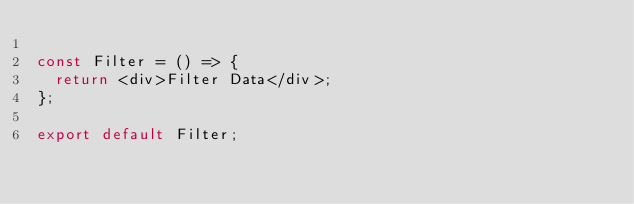Convert code to text. <code><loc_0><loc_0><loc_500><loc_500><_JavaScript_>
const Filter = () => {
  return <div>Filter Data</div>;
};

export default Filter;
</code> 